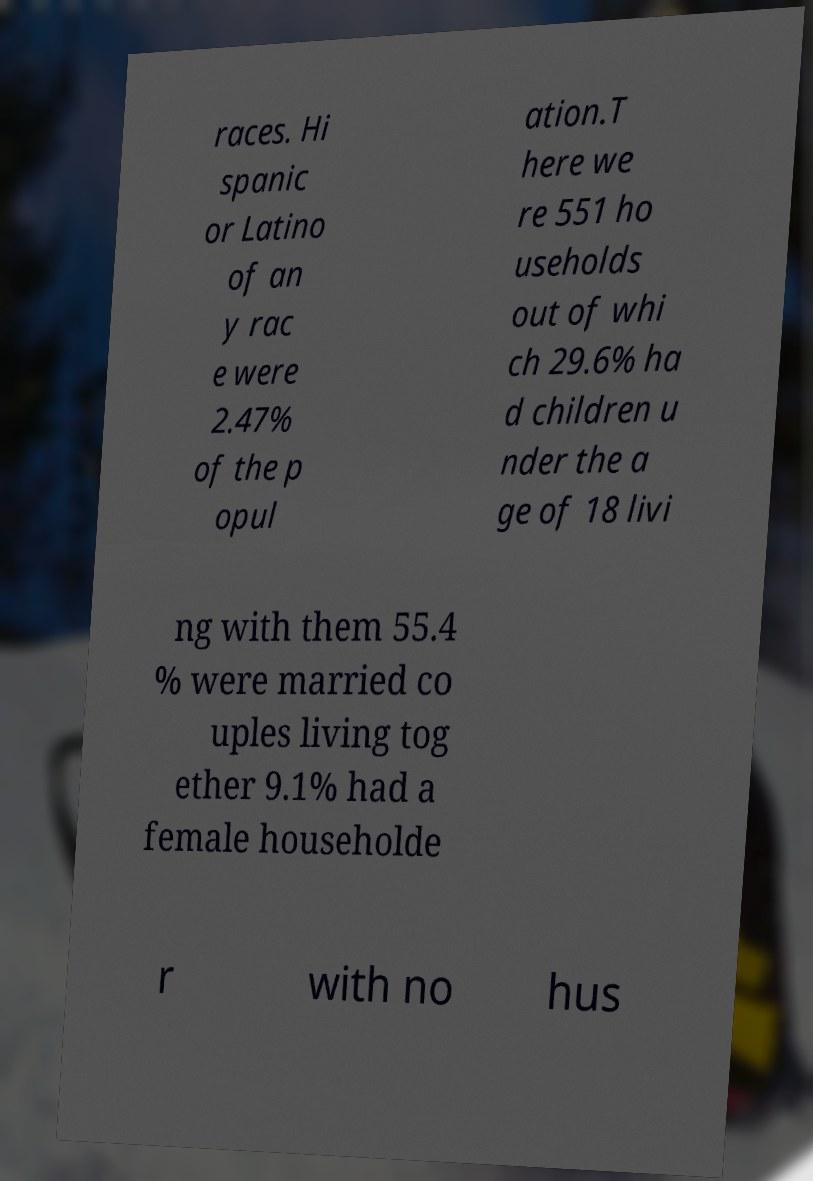Please read and relay the text visible in this image. What does it say? races. Hi spanic or Latino of an y rac e were 2.47% of the p opul ation.T here we re 551 ho useholds out of whi ch 29.6% ha d children u nder the a ge of 18 livi ng with them 55.4 % were married co uples living tog ether 9.1% had a female householde r with no hus 